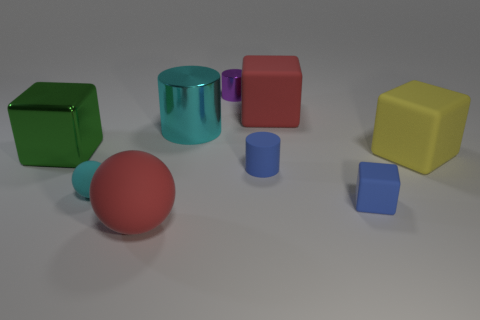What material is the tiny blue object that is behind the small cyan matte ball right of the large block on the left side of the small cyan rubber sphere?
Give a very brief answer. Rubber. Is the tiny purple metal thing the same shape as the large yellow rubber object?
Provide a succinct answer. No. What number of things are behind the tiny cyan object and in front of the tiny purple metal cylinder?
Your answer should be compact. 5. There is a big rubber cube to the right of the large matte block behind the big metallic block; what color is it?
Your response must be concise. Yellow. Are there an equal number of big metallic cylinders behind the big cyan shiny object and balls?
Provide a short and direct response. No. What number of small cylinders are on the left side of the rubber object on the left side of the red rubber thing that is to the left of the small purple object?
Your answer should be compact. 0. There is a ball that is in front of the tiny cyan rubber thing; what color is it?
Your response must be concise. Red. There is a thing that is both in front of the tiny cyan rubber thing and right of the tiny rubber cylinder; what is its material?
Your answer should be very brief. Rubber. How many objects are in front of the cylinder in front of the big yellow object?
Keep it short and to the point. 3. What is the shape of the big cyan shiny thing?
Provide a succinct answer. Cylinder. 